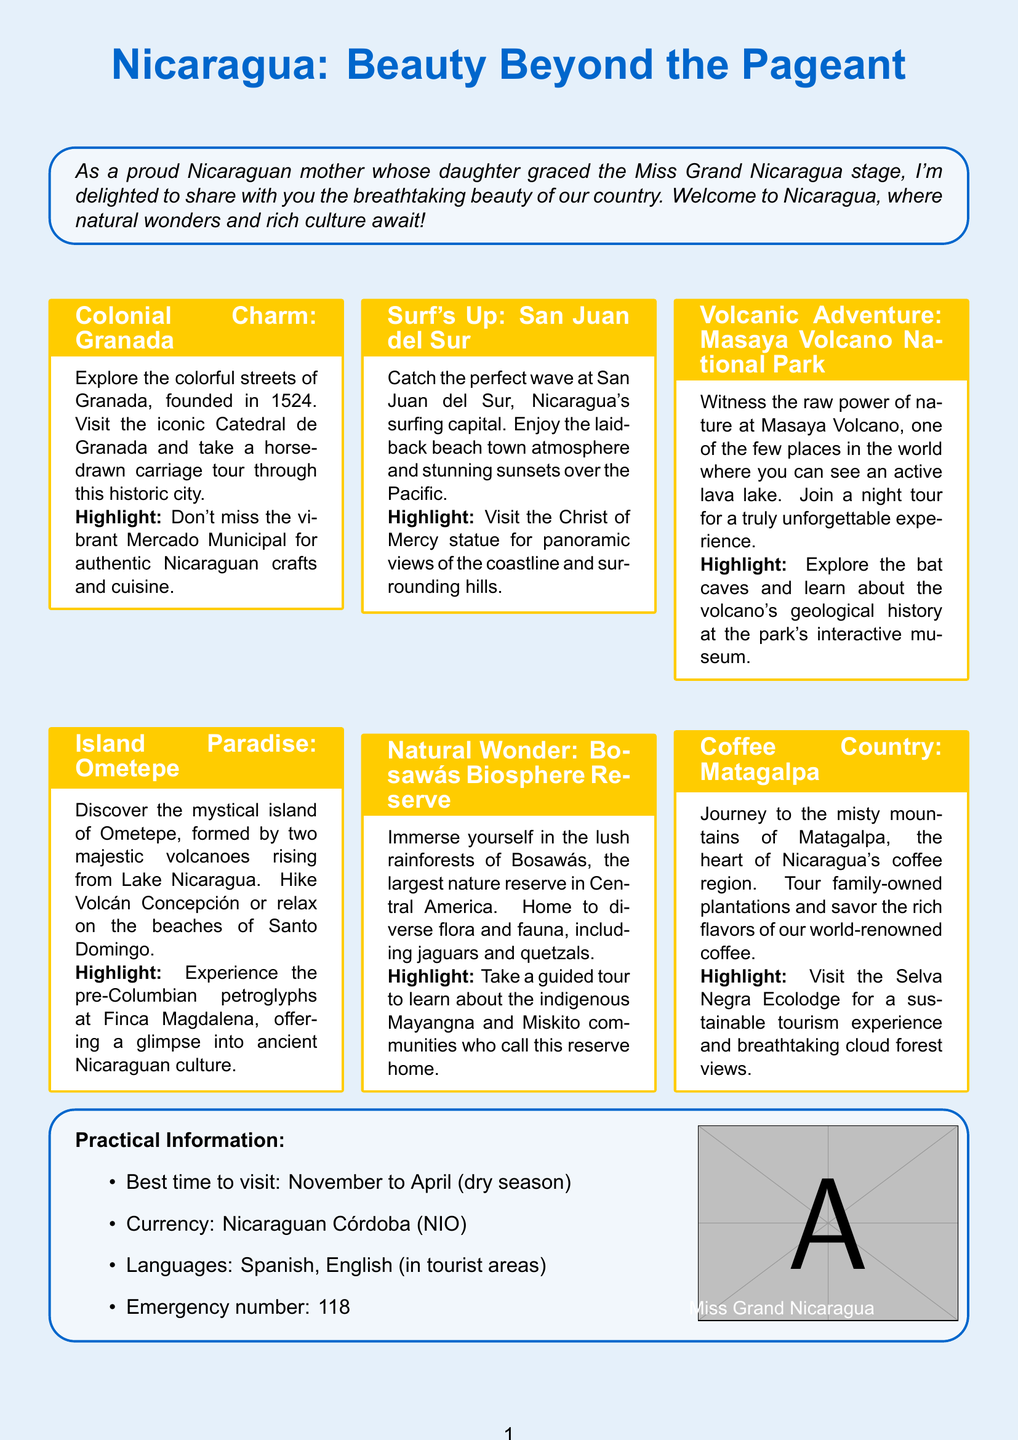What is the title of the brochure? The title of the brochure is provided prominently at the top.
Answer: Nicaragua: Beauty Beyond the Pageant Which city is known for its colorful streets and horse-drawn carriage tours? This location is explicitly described in the brochure section addressing colonial charm.
Answer: Granada What is the best time to visit Nicaragua? The brochure specifies the ideal time for visitors in the practical information section.
Answer: November to April What type of experience is highlighted at Finca Magdalena? This section describes a cultural experience available at a specific attraction.
Answer: Pre-Columbian petroglyphs What is the currency used in Nicaragua? The currency is listed in the practical information about financial details for visitors.
Answer: Nicaraguan Córdoba What can visitors do at San Juan del Sur? The brochure highlights activities specific to this surfing capital.
Answer: Surfing What is the emergency number in Nicaragua? This information is critical for visitors to know during their stay.
Answer: 118 What natural feature can be observed at Masaya Volcano? The text details what visitors can see related to this natural attraction.
Answer: Active lava lake What type of tours are recommended in Matagalpa? This section explains what activities are available to experience the region.
Answer: Coffee plantation tours 